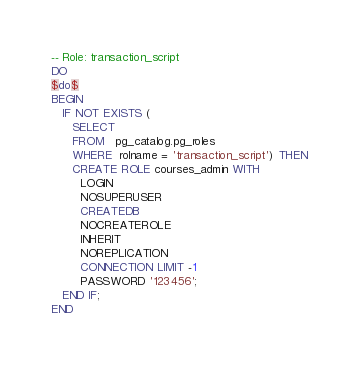Convert code to text. <code><loc_0><loc_0><loc_500><loc_500><_SQL_>-- Role: transaction_script
DO
$do$
BEGIN
   IF NOT EXISTS (
      SELECT
      FROM   pg_catalog.pg_roles
      WHERE  rolname = 'transaction_script') THEN
      CREATE ROLE courses_admin WITH
		LOGIN
		NOSUPERUSER
		CREATEDB
		NOCREATEROLE
		INHERIT
		NOREPLICATION
		CONNECTION LIMIT -1
		PASSWORD '123456';
   END IF;
END</code> 